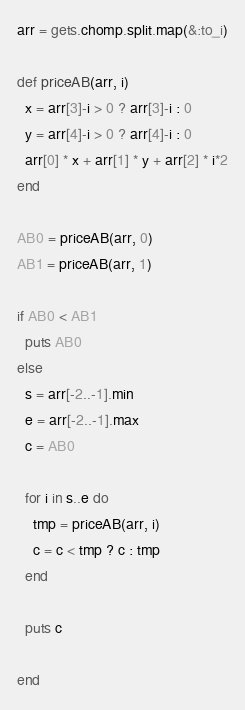Convert code to text. <code><loc_0><loc_0><loc_500><loc_500><_Ruby_>arr = gets.chomp.split.map(&:to_i)

def priceAB(arr, i)
  x = arr[3]-i > 0 ? arr[3]-i : 0
  y = arr[4]-i > 0 ? arr[4]-i : 0
  arr[0] * x + arr[1] * y + arr[2] * i*2
end

AB0 = priceAB(arr, 0)
AB1 = priceAB(arr, 1)

if AB0 < AB1
  puts AB0
else
  s = arr[-2..-1].min
  e = arr[-2..-1].max
  c = AB0

  for i in s..e do
    tmp = priceAB(arr, i)
    c = c < tmp ? c : tmp
  end

  puts c

end

</code> 